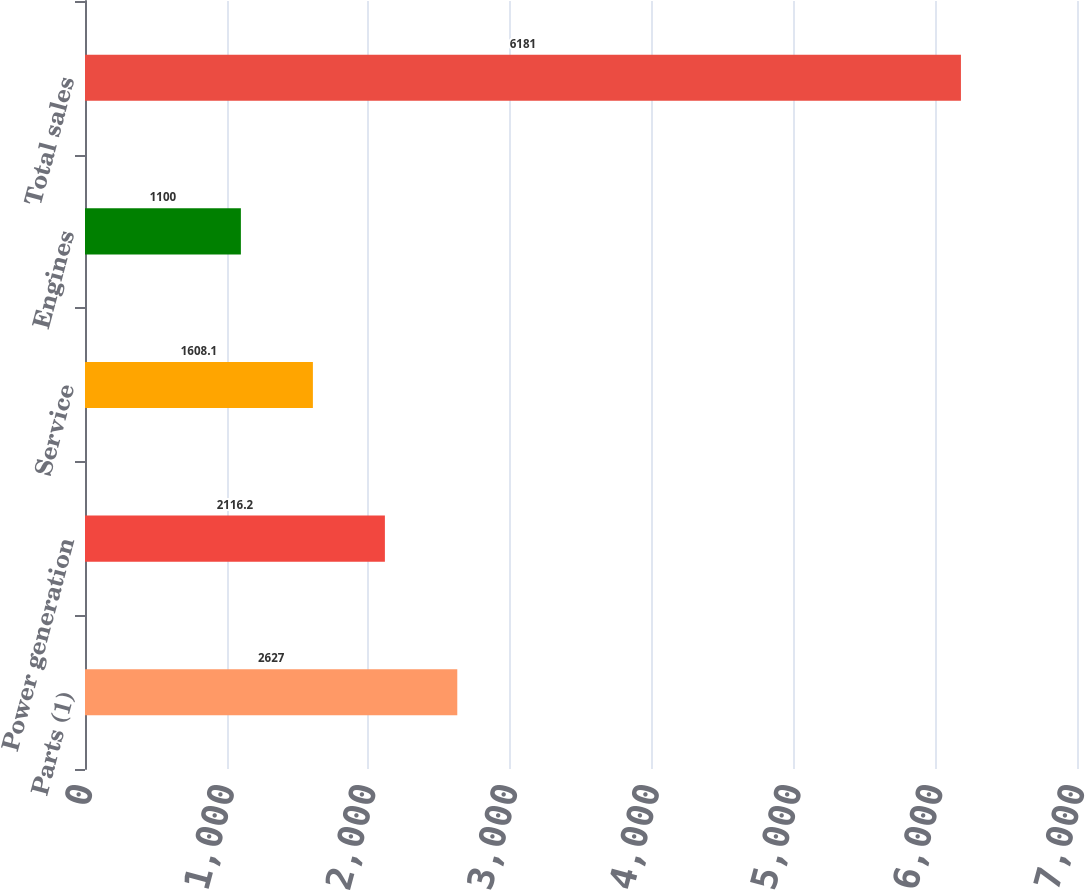Convert chart to OTSL. <chart><loc_0><loc_0><loc_500><loc_500><bar_chart><fcel>Parts (1)<fcel>Power generation<fcel>Service<fcel>Engines<fcel>Total sales<nl><fcel>2627<fcel>2116.2<fcel>1608.1<fcel>1100<fcel>6181<nl></chart> 